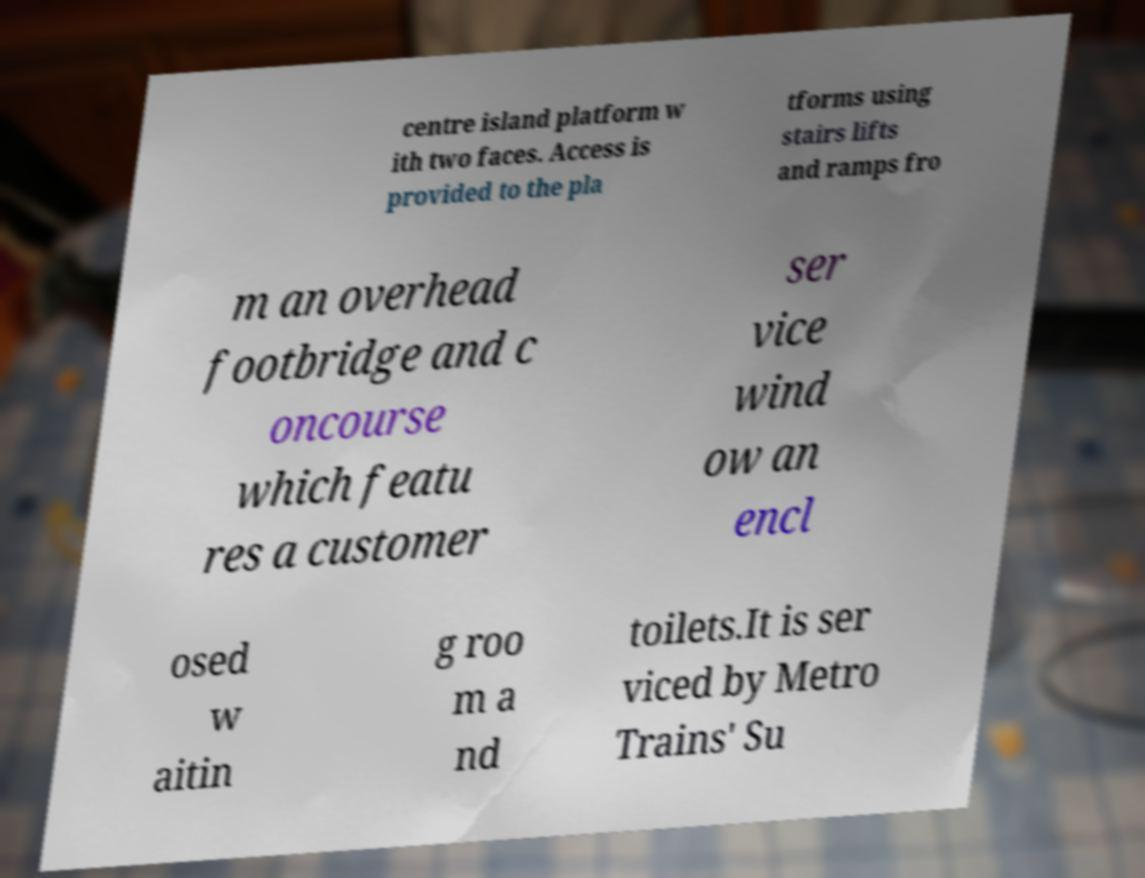I need the written content from this picture converted into text. Can you do that? centre island platform w ith two faces. Access is provided to the pla tforms using stairs lifts and ramps fro m an overhead footbridge and c oncourse which featu res a customer ser vice wind ow an encl osed w aitin g roo m a nd toilets.It is ser viced by Metro Trains' Su 